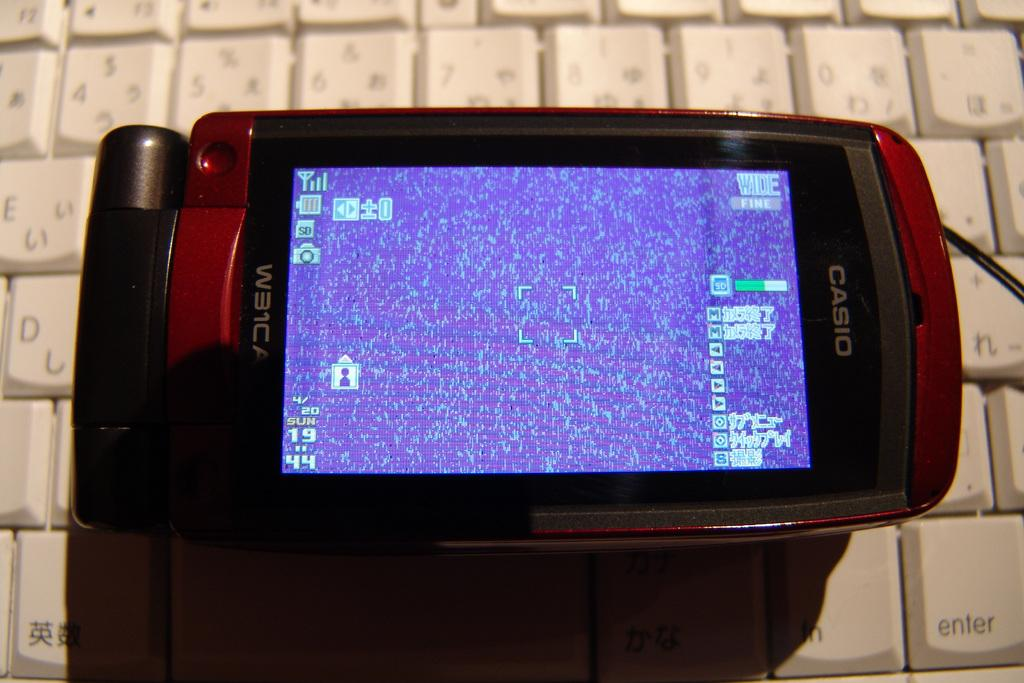<image>
Offer a succinct explanation of the picture presented. A CASIO device that has SUN 19 on the bottom left of the screen 